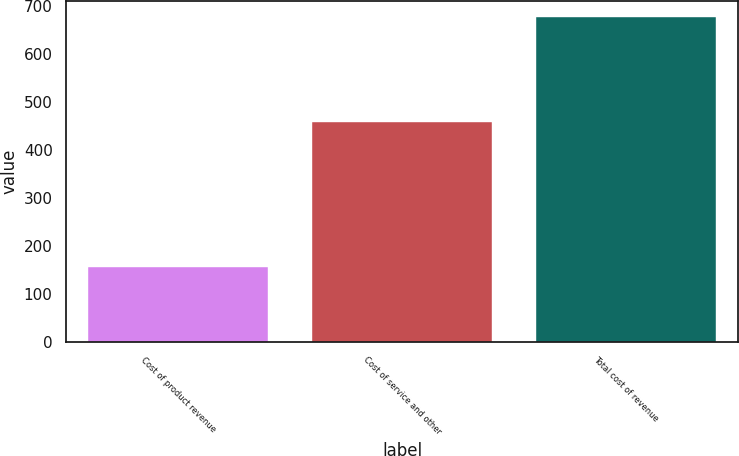<chart> <loc_0><loc_0><loc_500><loc_500><bar_chart><fcel>Cost of product revenue<fcel>Cost of service and other<fcel>Total cost of revenue<nl><fcel>157.2<fcel>458.5<fcel>676.9<nl></chart> 